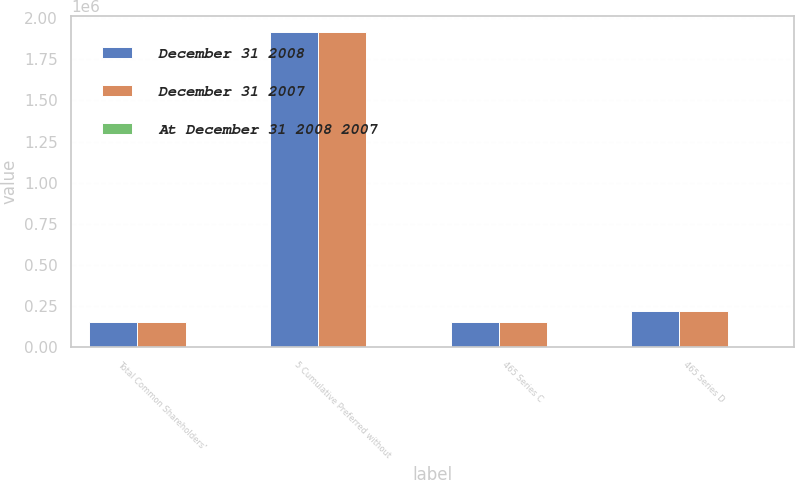<chart> <loc_0><loc_0><loc_500><loc_500><stacked_bar_chart><ecel><fcel>Total Common Shareholders'<fcel>5 Cumulative Preferred without<fcel>465 Series C<fcel>465 Series D<nl><fcel>December 31 2008<fcel>153296<fcel>1.91532e+06<fcel>153296<fcel>222330<nl><fcel>December 31 2007<fcel>153296<fcel>1.91532e+06<fcel>153296<fcel>222330<nl><fcel>At December 31 2008 2007<fcel>9765<fcel>175<fcel>16<fcel>22<nl></chart> 